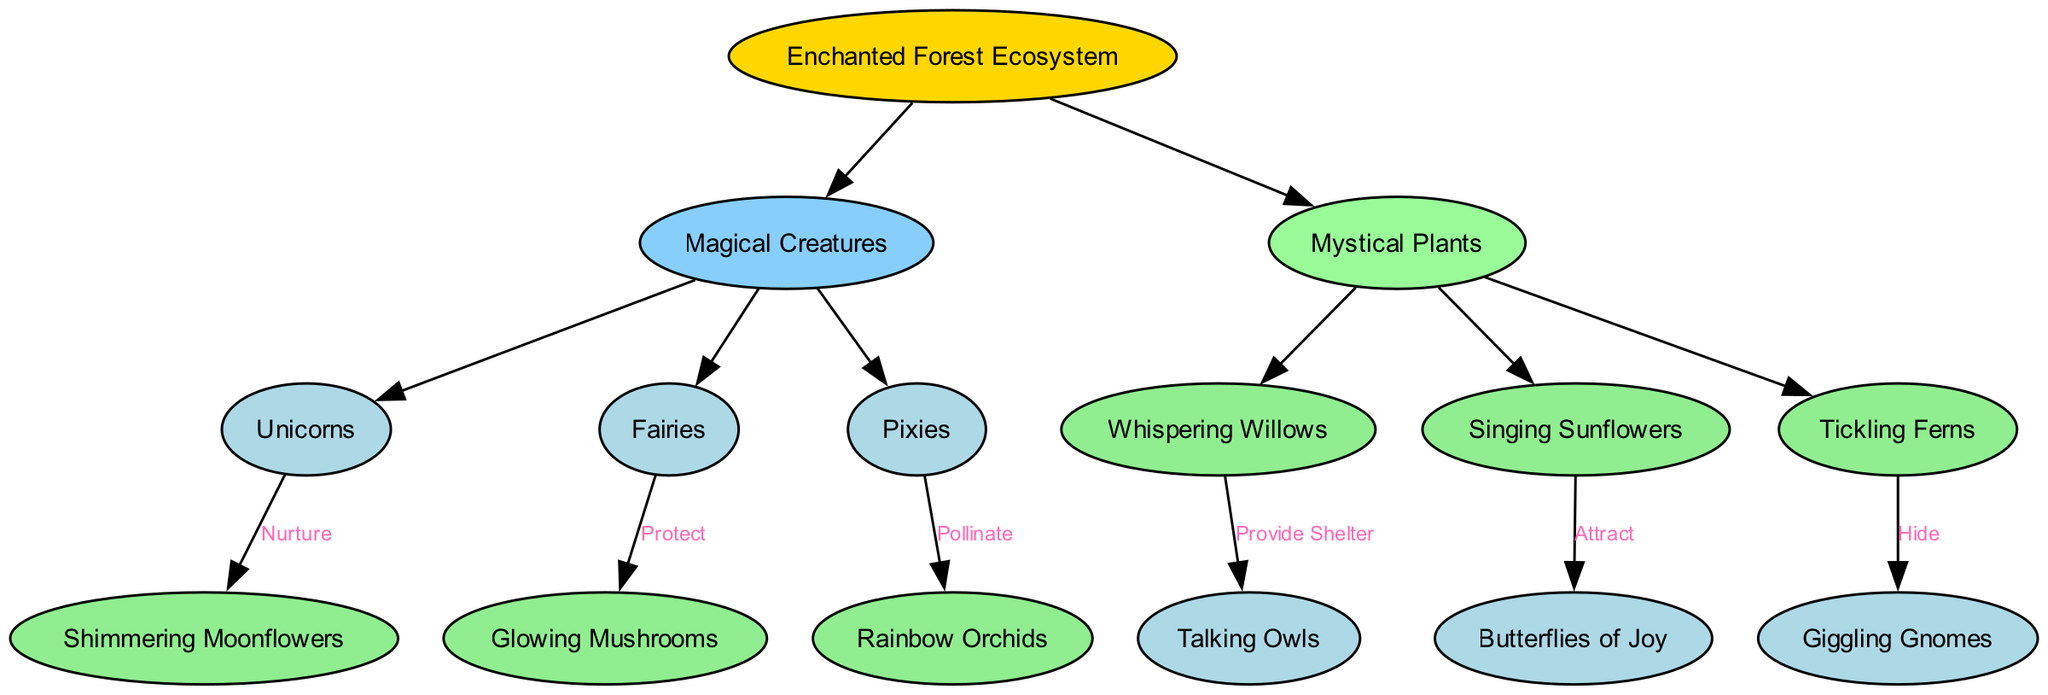What magical creature nurtures Shimmering Moonflowers? The diagram shows that Unicorns have a relationship with Shimmering Moonflowers where they nurture them. This is indicated by the edge connecting Unicorns to Shimmering Moonflowers labeled "Nurture."
Answer: Unicorns How many magical creatures are in the diagram? By examining the diagram, we see three magical creatures listed: Unicorns, Fairies, and Pixies. Therefore, the total count is three.
Answer: 3 What relationship do Fairies have with Glowing Mushrooms? The diagram indicates that Fairies have a protective relationship with Glowing Mushrooms. This is displayed through the edge connecting Fairies and Glowing Mushrooms labeled "Protect."
Answer: Protect Which mystical plant attracts Butterflies of Joy? The diagram illustrates that Singing Sunflowers attract Butterflies of Joy, as shown by the edge that links Singing Sunflowers with Butterflies of Joy labeled "Attract."
Answer: Singing Sunflowers How many mystical plants are connected to creatures in the ecosystem? The diagram reveals three mystical plants: Whispering Willows, Singing Sunflowers, and Tickling Ferns, each connected to a creature through a specific relationship, indicating that there are three connections.
Answer: 3 What do Tickling Ferns do regarding Giggling Gnomes? The diagram shows that Tickling Ferns have a hiding relationship with Giggling Gnomes. This is indicated by the edge connecting Tickling Ferns to Giggling Gnomes labeled "Hide."
Answer: Hide Which magical creature is connected to Rainbow Orchids? According to the diagram, Pixies are the magical creatures that pollinate Rainbow Orchids. This relationship is represented by the edge labeled "Pollinate."
Answer: Pixies What role do Whispering Willows play in the ecosystem? In the diagram, Whispering Willows provide shelter for Talking Owls. This connection is shown by the edge that links Whispering Willows to Talking Owls labeled "Provide Shelter."
Answer: Provide Shelter What is the total number of edges in the diagram? By counting the edges, which represent the relationships, we see there are six edges: three from magical creatures to plants and three from plants to creatures.
Answer: 6 